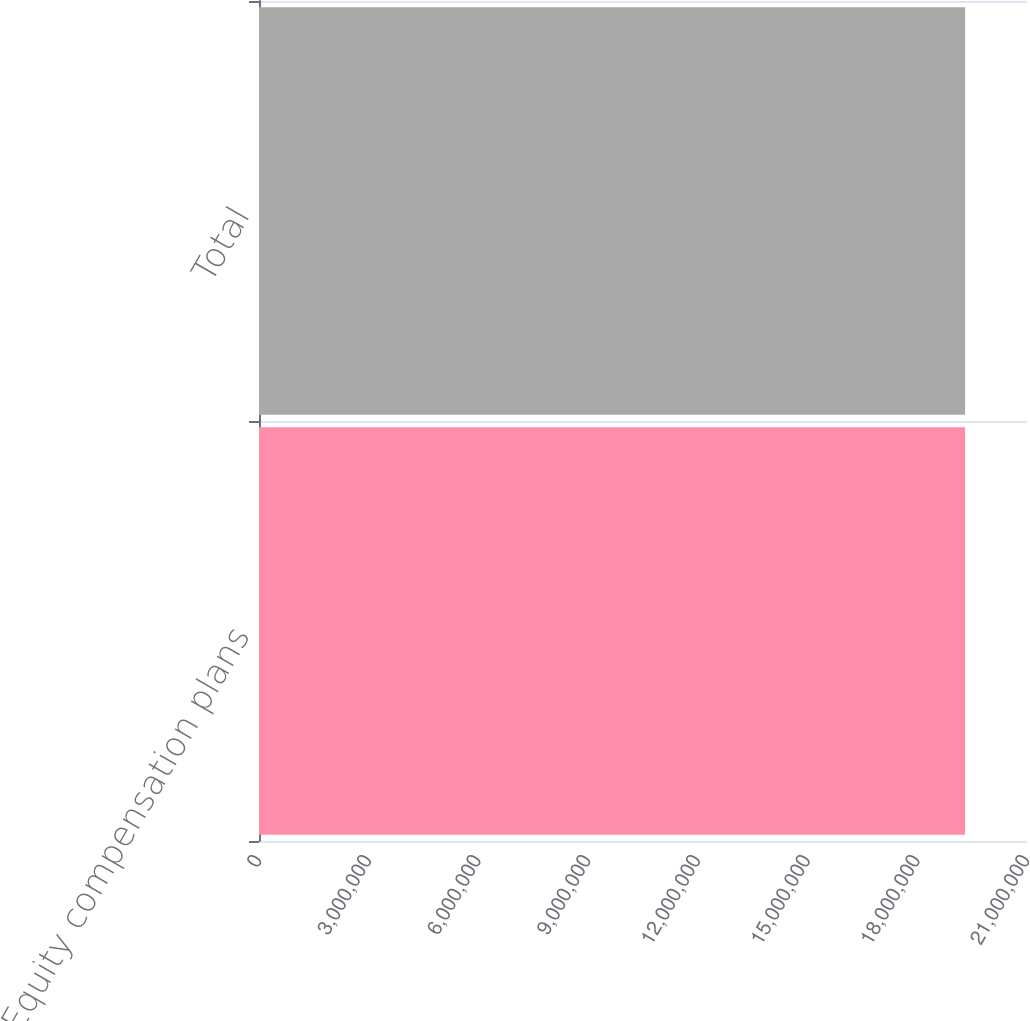Convert chart to OTSL. <chart><loc_0><loc_0><loc_500><loc_500><bar_chart><fcel>Equity compensation plans<fcel>Total<nl><fcel>1.93081e+07<fcel>1.93081e+07<nl></chart> 